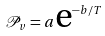<formula> <loc_0><loc_0><loc_500><loc_500>\mathcal { P } _ { v } = a \text {e} ^ { - b / T }</formula> 